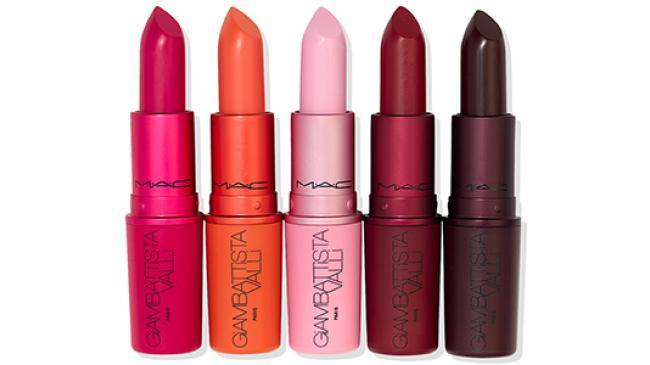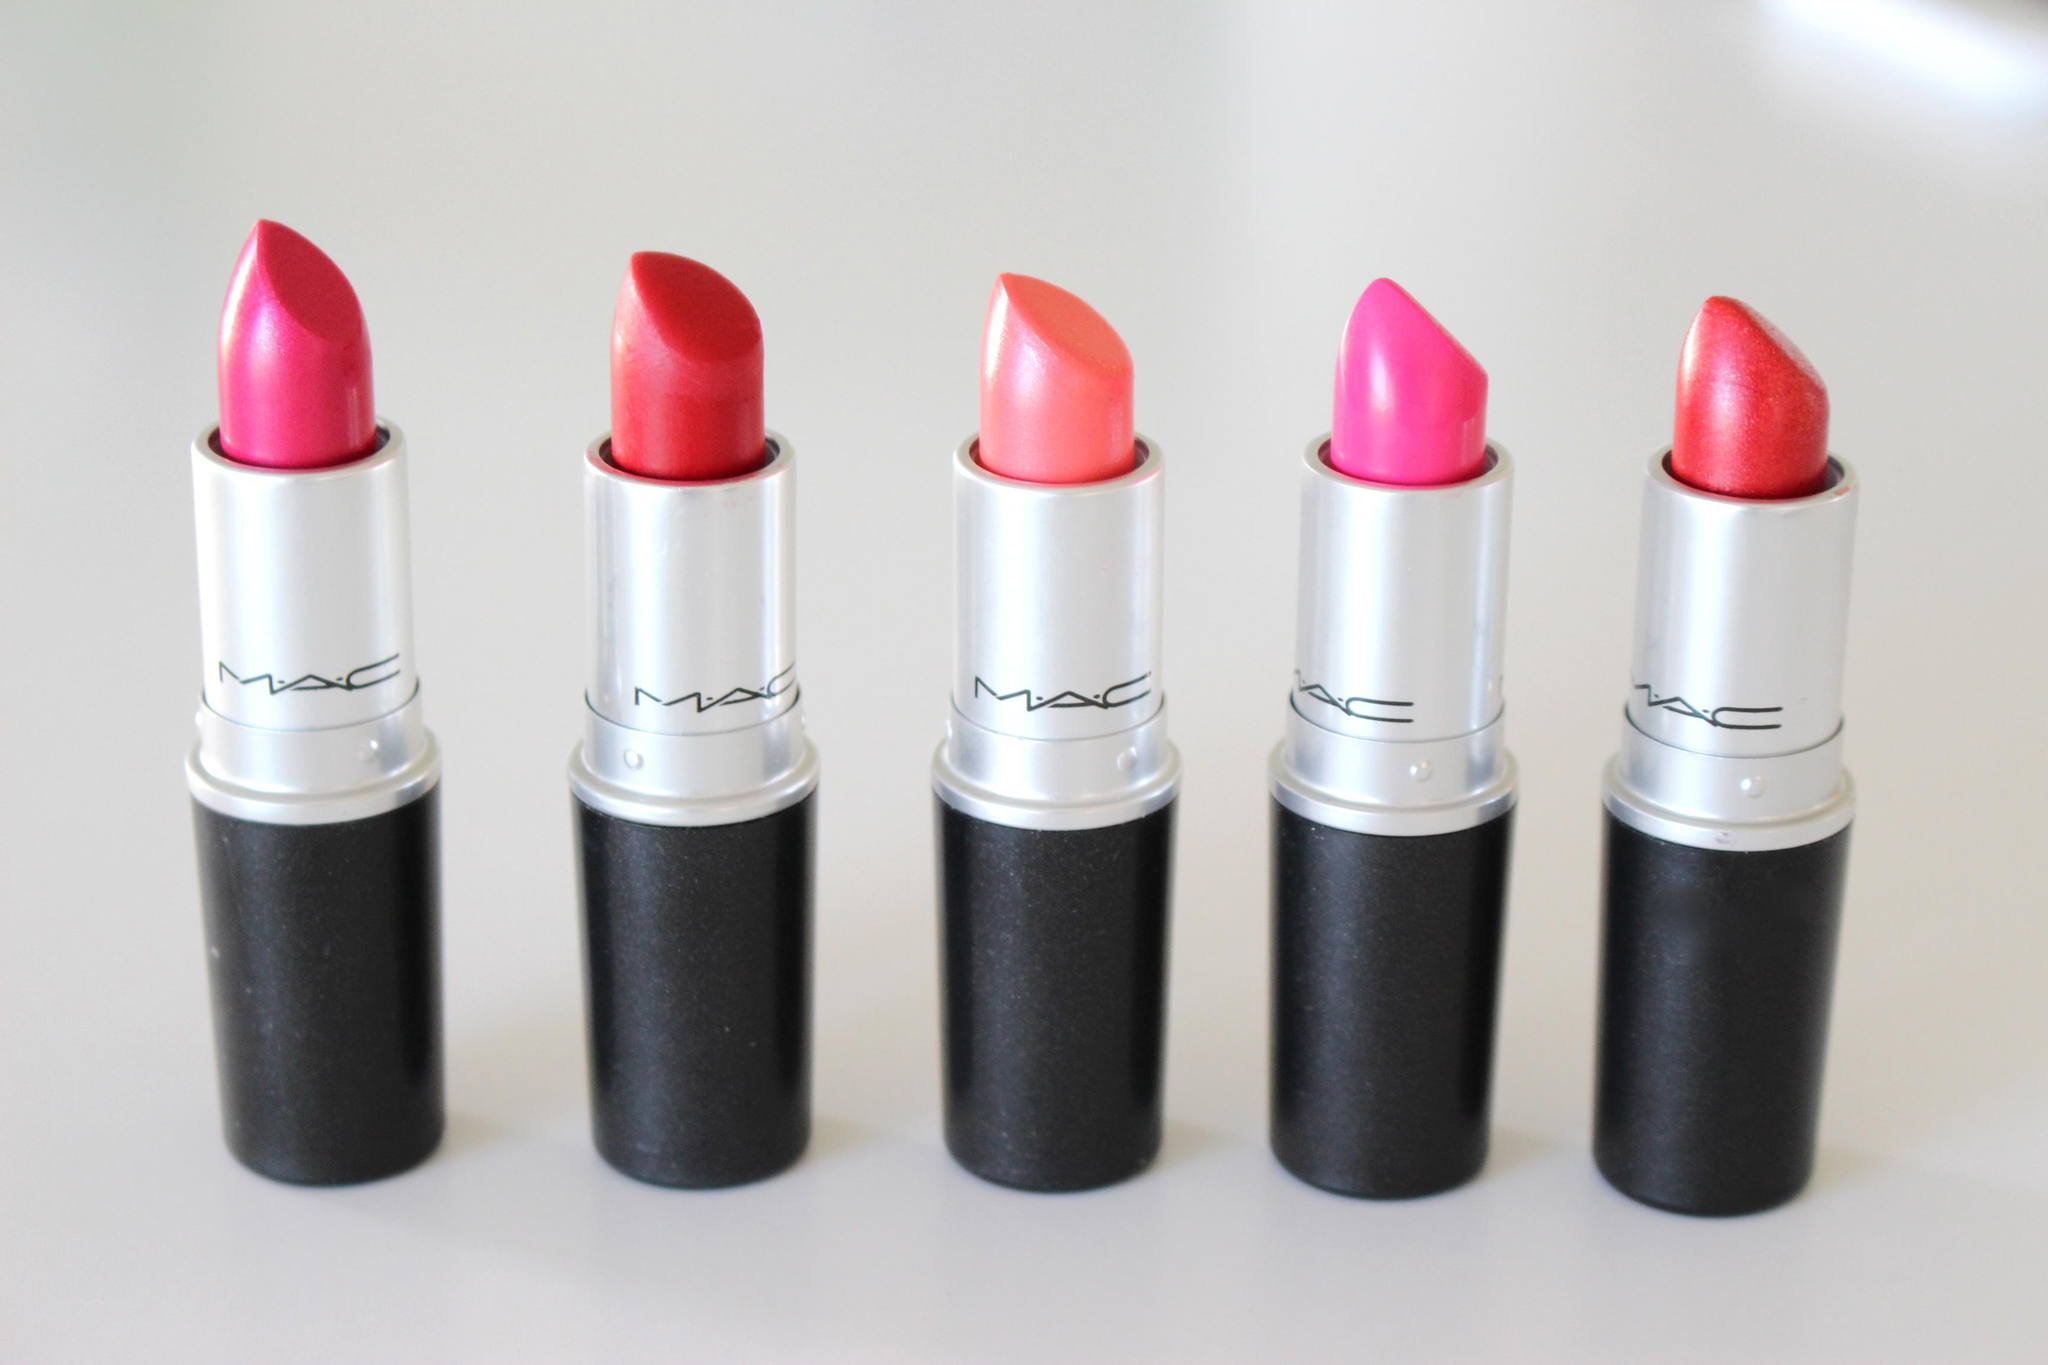The first image is the image on the left, the second image is the image on the right. Given the left and right images, does the statement "Lip shapes are depicted in one or more images." hold true? Answer yes or no. No. 